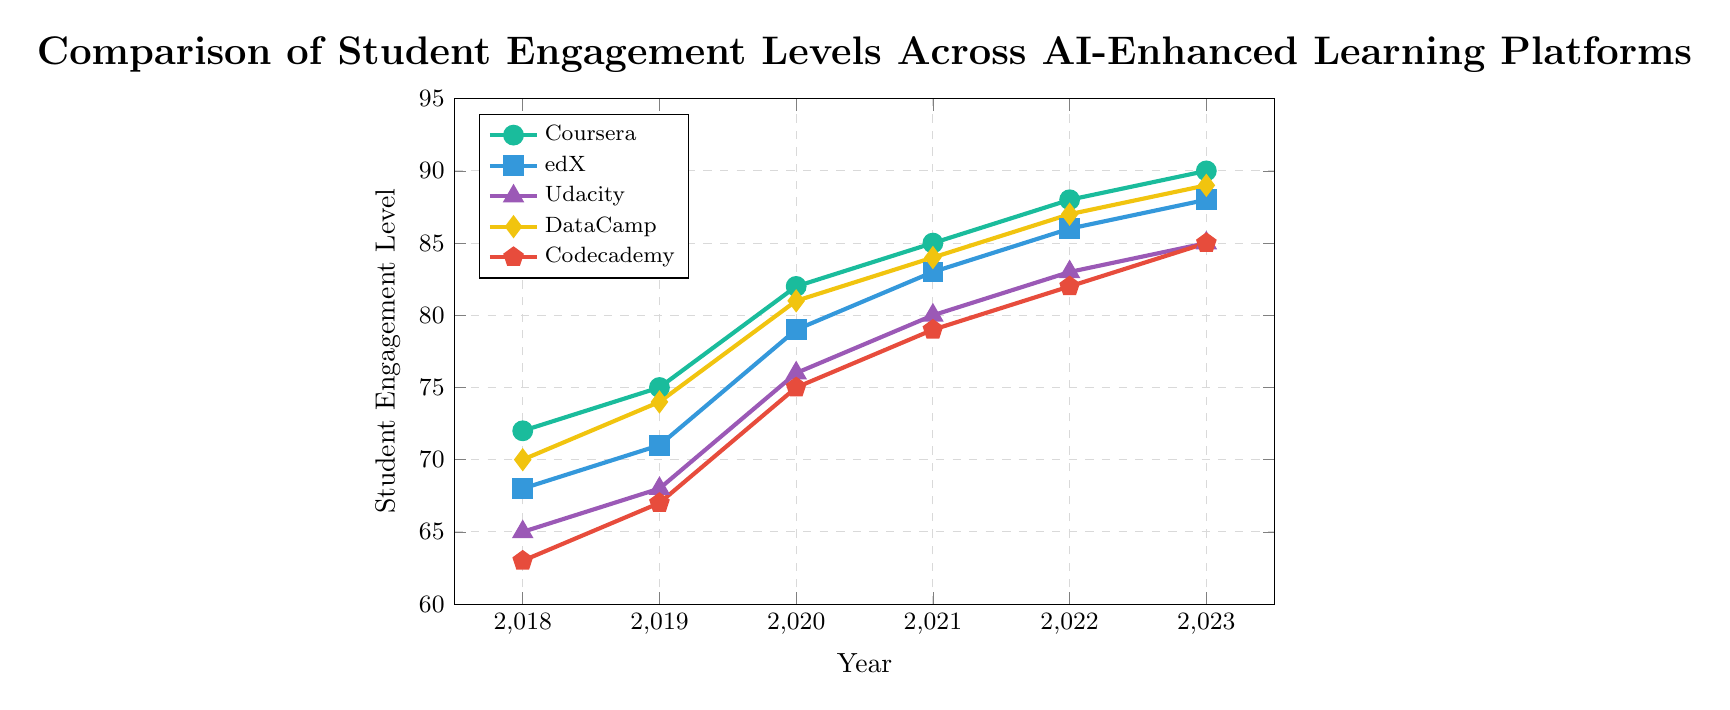What is the trend in student engagement levels for Coursera from 2018 to 2023? The engagement levels start at 72 in 2018 and steadily increase year by year, reaching 90 in 2023. This indicates a consistent upward trend over the given period.
Answer: Upward trend Which platform had the highest student engagement level in 2023? To determine this, look at the 2023 values for all platforms: Coursera (90), edX (88), Udacity (85), DataCamp (89), and Codecademy (85). Coursera has the highest value of 90.
Answer: Coursera How does the engagement level of DataCamp in 2021 compare to that of Codecademy in the same year? Consult the 2021 values: DataCamp (84) and Codecademy (79). DataCamp's engagement level is higher than Codecademy's.
Answer: DataCamp's is higher Which platform shows the largest increase in student engagement from 2018 to 2023? Calculate the increase for each platform: Coursera (90-72=18), edX (88-68=20), Udacity (85-65=20), DataCamp (89-70=19), Codecademy (85-63=22). Codecademy shows the largest increase with a value of 22.
Answer: Codecademy What was the student engagement level for Udacity and DataCamp in 2020? Look at the values for 2020: Udacity (76) and DataCamp (81).
Answer: Udacity: 76, DataCamp: 81 Which platform had a lower engagement level in 2019, edX or Codecademy? Check the 2019 values: edX (71) and Codecademy (67). Codecademy has a lower value.
Answer: Codecademy What is the average engagement level of edX from 2018 to 2023? Sum the values (68 + 71 + 79 + 83 + 86 + 88 = 475) and divide by the number of years (6). The average is 475/6 ≈ 79.17.
Answer: 79.17 If we rank the platforms based on their engagement levels in 2022, what position does Udacity hold? Compare 2022 values: Coursera (88), edX (86), Udacity (83), DataCamp (87), Codecademy (82). The ranking is Coursera, DataCamp, edX, Udacity, Codecademy. Udacity holds 4th position.
Answer: 4th By how many points did the engagement level of Coursera increase between 2019 and 2020? Subtract 2019 value from 2020 value for Coursera: 82 - 75 = 7.
Answer: 7 